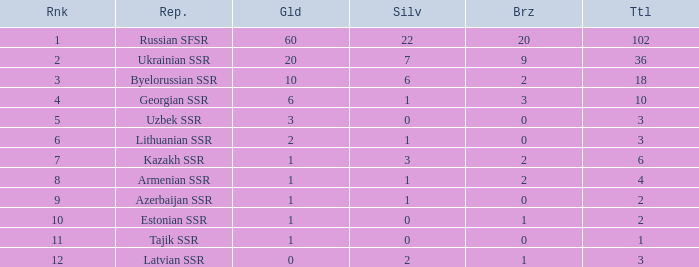What is the highest number of bronzes for teams ranked number 7 with more than 0 silver? 2.0. 